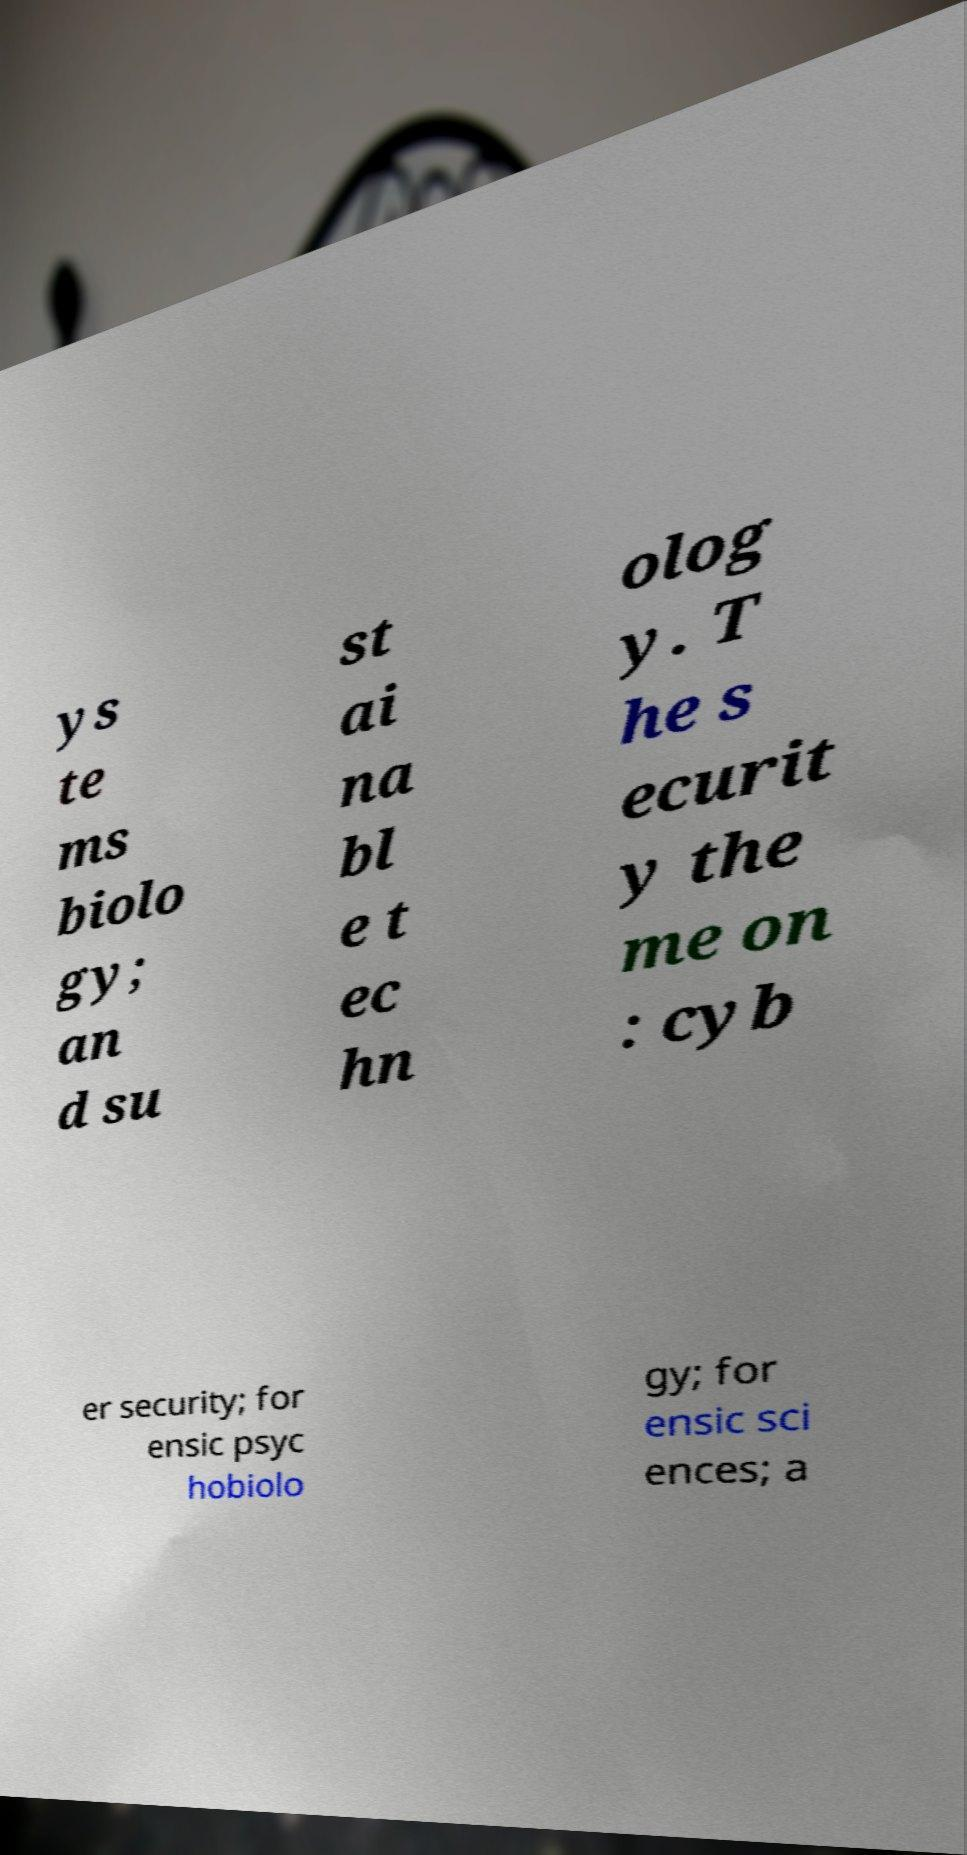Can you accurately transcribe the text from the provided image for me? ys te ms biolo gy; an d su st ai na bl e t ec hn olog y. T he s ecurit y the me on : cyb er security; for ensic psyc hobiolo gy; for ensic sci ences; a 